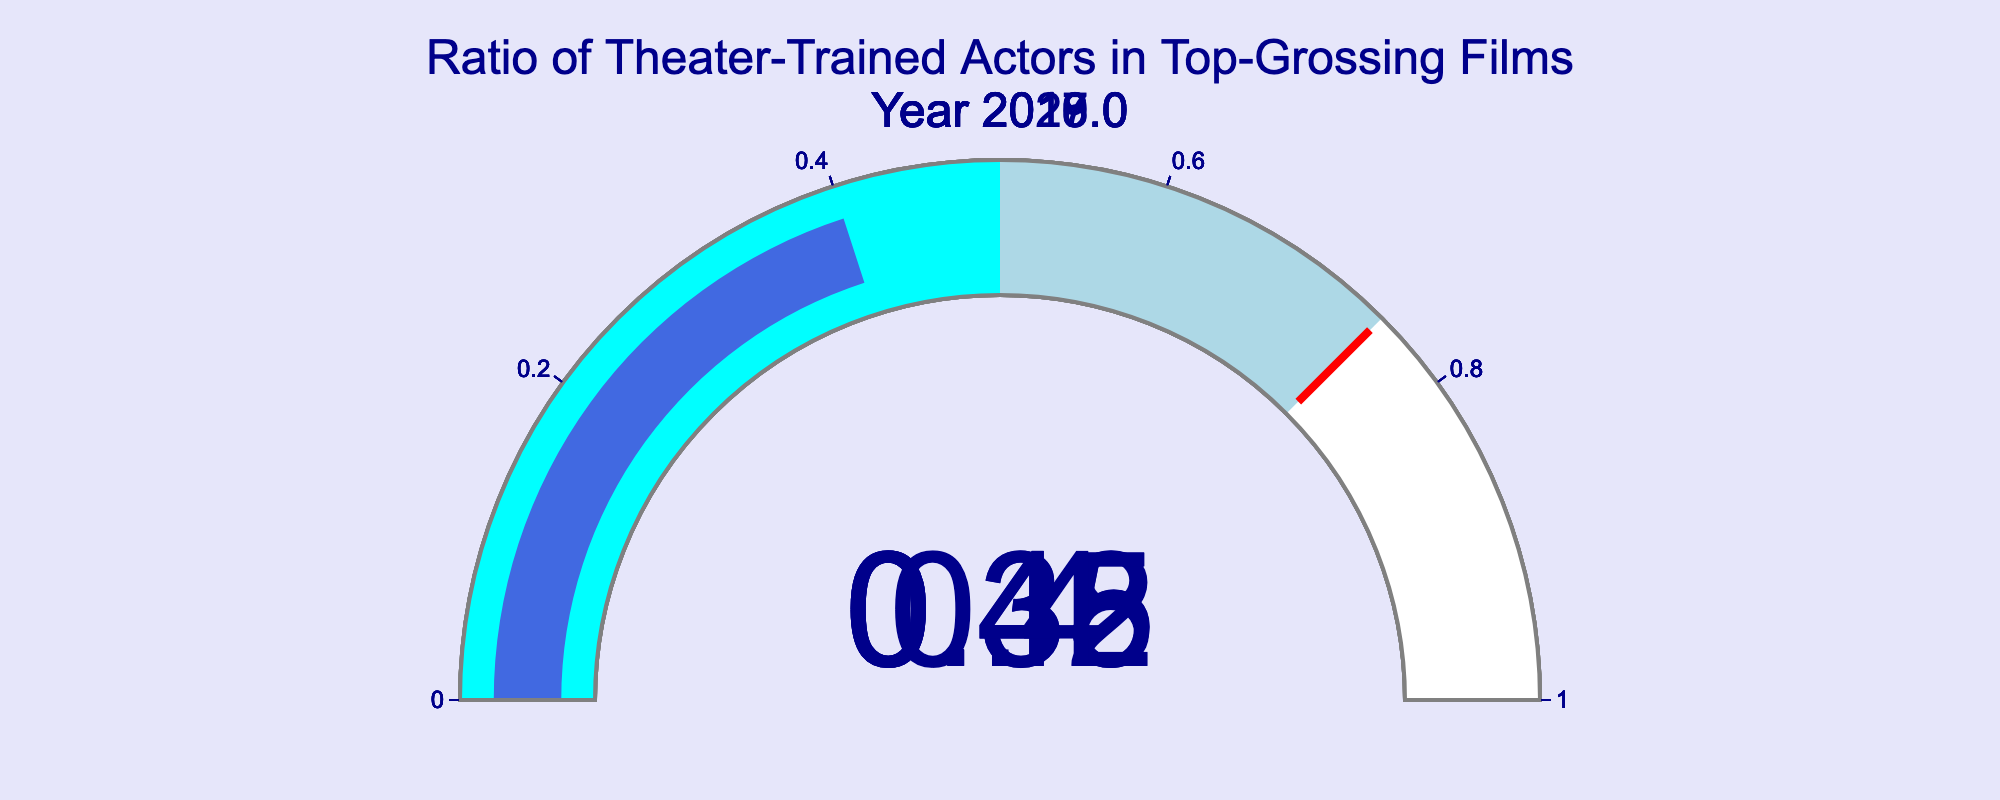What's the title of the figure? The title is positioned at the top-center of the figure. It reads: "Ratio of Theater-Trained Actors in Top-Grossing Films"
Answer: Ratio of Theater-Trained Actors in Top-Grossing Films How many years of data are displayed in the figure? By counting the individual gauge charts, we see that data for five different years is shown. Each gauge corresponds to one year.
Answer: 5 Which year had the highest ratio of theater-trained actors? By observing the values on the gauge charts, the year 2017 has the highest ratio, displayed as 0.45.
Answer: 2017 Which year had the lowest ratio of theater-trained actors? From the values on the gauge charts, the year 2020 has the lowest ratio, shown as 0.35.
Answer: 2020 What is the average ratio of theater-trained actors over the given years? Summing up the ratios for all five years: 0.35 (2020) + 0.42 (2019) + 0.38 (2018) + 0.45 (2017) + 0.40 (2016) = 2.00, then dividing by the number of years: 2.00 / 5 = 0.40
Answer: 0.40 How much higher is the ratio of theater-trained actors in 2017 compared to 2020? Subtracting the ratio of 2020 from that of 2017: 0.45 (2017) - 0.35 (2020) = 0.10
Answer: 0.10 Is the value for the year 2019 closer to the maximum or the minimum ratio displayed? The maximum ratio is 0.45 and the minimum is 0.35. The midpoint is (0.45 + 0.35) / 2 = 0.40. The 2019 ratio is 0.42, which is closer to 0.45 (maximum).
Answer: Maximum Outside of 2017, in which other year does the ratio exceed the average ratio of all years? The computed average ratio is 0.40.  The ratios for 2019 (0.42) and 2016 (0.40) are compared, and only 2019 exceeds the average.
Answer: 2019 Which years have a ratio equal to or above the average ratio? The average ratio is 0.40. The years with ratios equal to or above are 2017 (0.45), 2019 (0.42), and 2016 (0.40).
Answer: 2017, 2019, 2016 